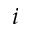<formula> <loc_0><loc_0><loc_500><loc_500>i</formula> 